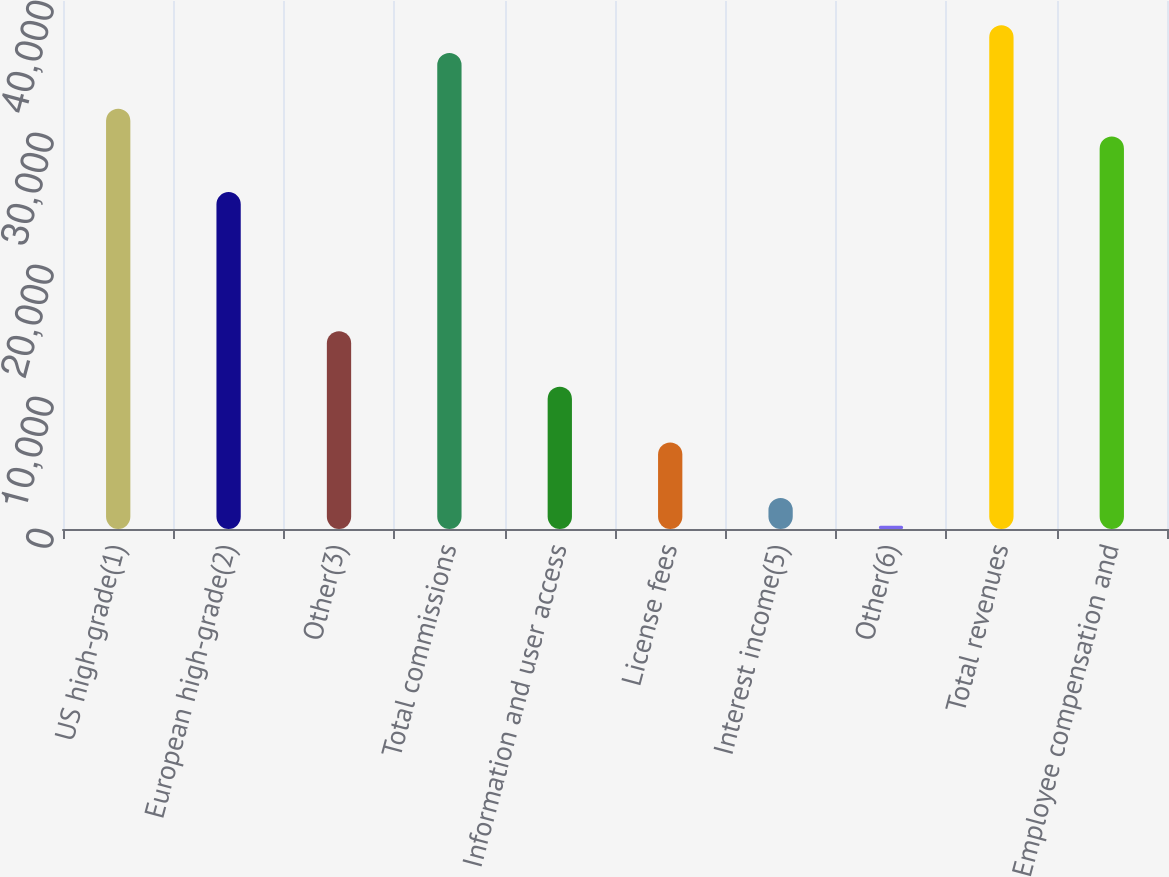Convert chart. <chart><loc_0><loc_0><loc_500><loc_500><bar_chart><fcel>US high-grade(1)<fcel>European high-grade(2)<fcel>Other(3)<fcel>Total commissions<fcel>Information and user access<fcel>License fees<fcel>Interest income(5)<fcel>Other(6)<fcel>Total revenues<fcel>Employee compensation and<nl><fcel>31842<fcel>25521.6<fcel>14987.6<fcel>36055.6<fcel>10774<fcel>6560.4<fcel>2346.8<fcel>240<fcel>38162.4<fcel>29735.2<nl></chart> 